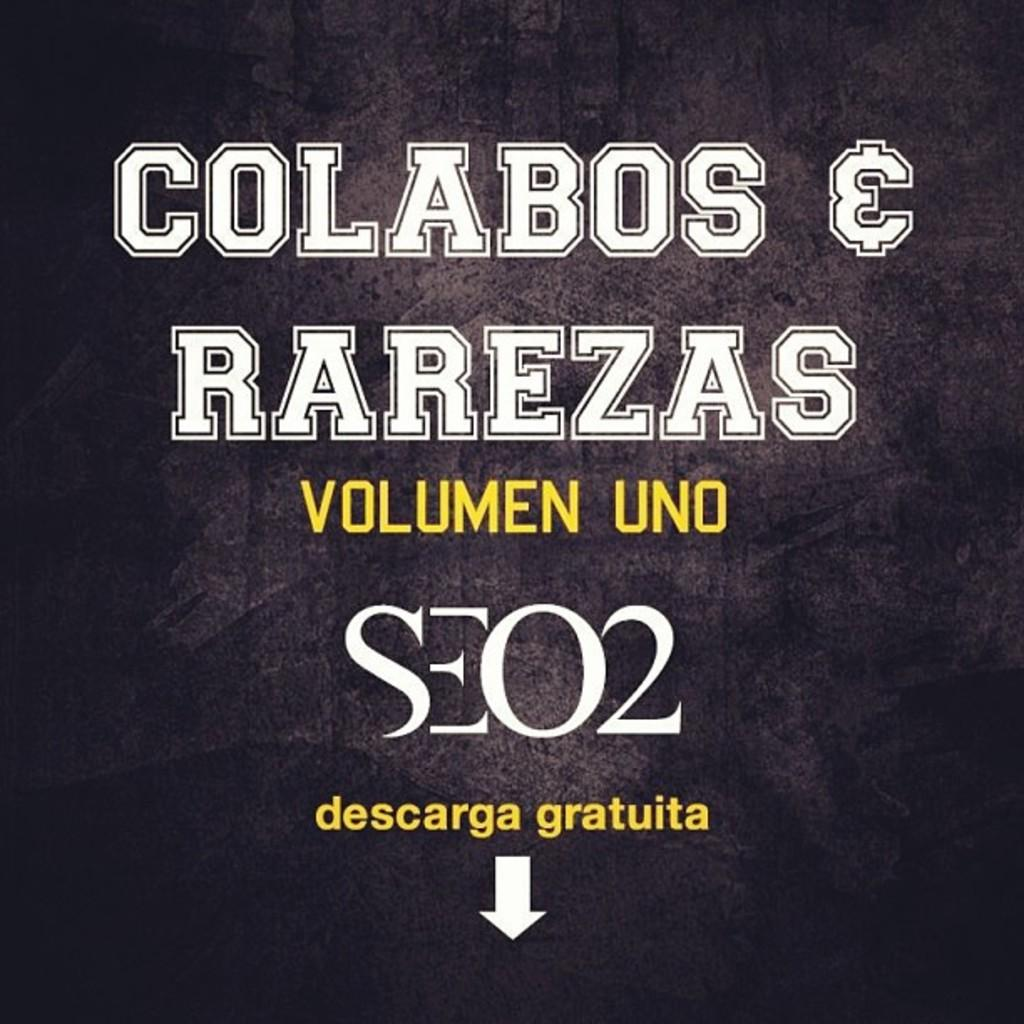<image>
Write a terse but informative summary of the picture. A black sign with white and yellow lettering with Colabos & Rarezas at the top. 